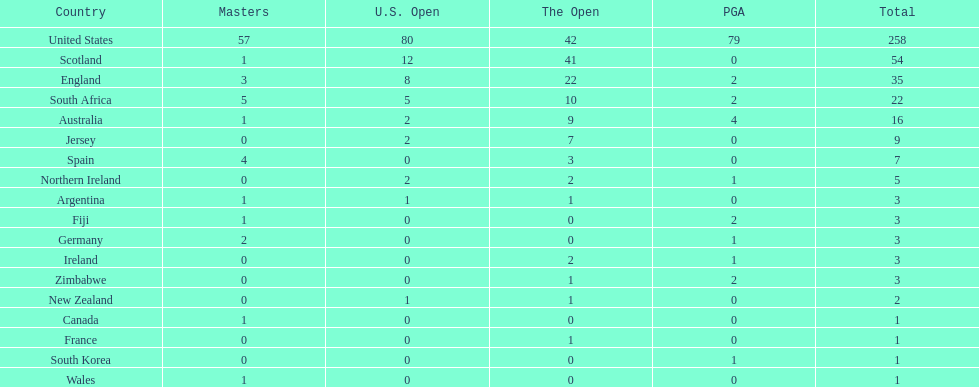How many golfers from zimbabwe have won pga championships? 2. 